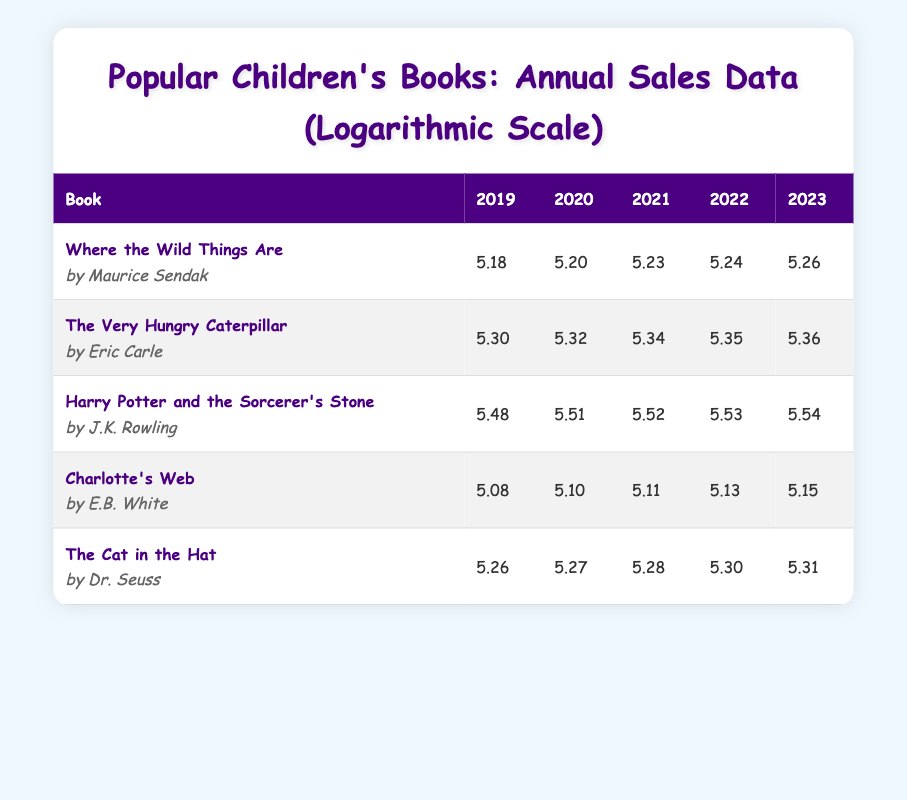What's the logarithmic value of the annual sales for "Harry Potter and the Sorcerer's Stone" in 2023? The table shows that the logarithmic value of the sales for "Harry Potter and the Sorcerer's Stone" in 2023 is 5.54, which is directly listed under the 2023 column.
Answer: 5.54 Which book had the highest logarithmic value in 2022? Referring to the 2022 column, "Harry Potter and the Sorcerer's Stone" has the highest logarithmic value at 5.53, compared to others in the same year.
Answer: Harry Potter and the Sorcerer's Stone What is the difference between the logarithmic values of "Where the Wild Things Are" in 2019 and 2023? In 2019, the value is 5.18 and in 2023 it is 5.26. The difference is 5.26 - 5.18 = 0.08.
Answer: 0.08 Is the logarithmic value for "The Very Hungry Caterpillar" in 2021 greater than 5.30? Looking at the 2021 column, the value for "The Very Hungry Caterpillar" is 5.34, which is indeed greater than 5.30.
Answer: Yes What is the average logarithmic value for "Charlotte's Web" over the five years? The values are 5.08, 5.10, 5.11, 5.13, and 5.15. Summing these values gives 5.08 + 5.10 + 5.11 + 5.13 + 5.15 = 25.57. Dividing by 5 yields an average of 25.57 / 5 = 5.115.
Answer: 5.115 Which book had the smallest logarithmic value in 2020? "Charlotte's Web" has a logarithmic value of 5.10 in 2020, which is the smallest compared to the other books in the same column.
Answer: Charlotte's Web How much did the logarithmic value of "The Cat in the Hat" increase from 2019 to 2023? The value in 2019 is 5.26 and in 2023 it is 5.31. The increase is calculated as 5.31 - 5.26 = 0.05.
Answer: 0.05 Was the sales growth for "Harry Potter and the Sorcerer's Stone" steady over the years? By checking the values from 2019 (5.48) to 2023 (5.54), the logarithmic values consistently increased each year, indicating a steady growth trend.
Answer: Yes What is the total logarithmic value for "The Very Hungry Caterpillar" from 2019 to 2023? The values are 5.30, 5.32, 5.34, 5.35, and 5.36. Adding these gives 5.30 + 5.32 + 5.34 + 5.35 + 5.36 = 26.67.
Answer: 26.67 